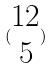<formula> <loc_0><loc_0><loc_500><loc_500>( \begin{matrix} 1 2 \\ 5 \end{matrix} )</formula> 